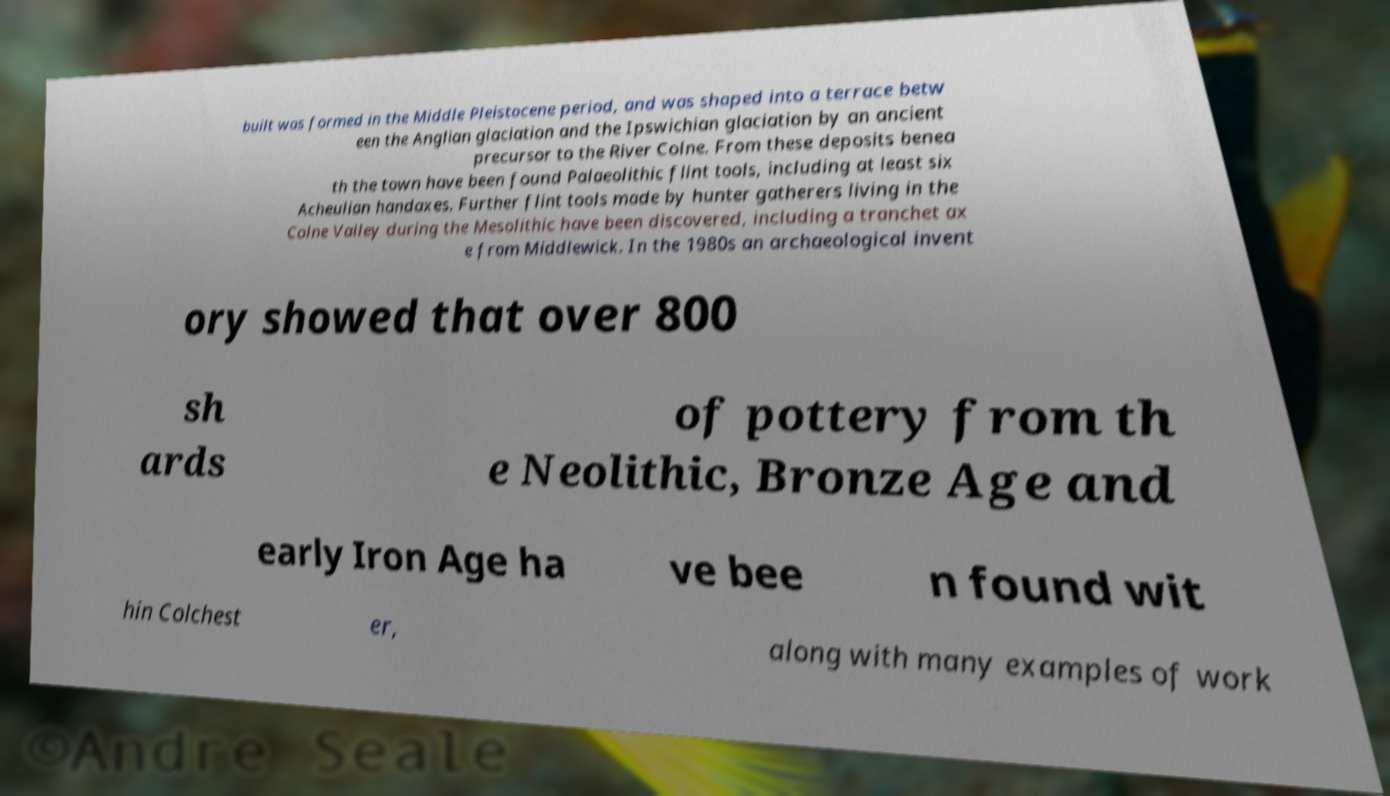For documentation purposes, I need the text within this image transcribed. Could you provide that? built was formed in the Middle Pleistocene period, and was shaped into a terrace betw een the Anglian glaciation and the Ipswichian glaciation by an ancient precursor to the River Colne. From these deposits benea th the town have been found Palaeolithic flint tools, including at least six Acheulian handaxes. Further flint tools made by hunter gatherers living in the Colne Valley during the Mesolithic have been discovered, including a tranchet ax e from Middlewick. In the 1980s an archaeological invent ory showed that over 800 sh ards of pottery from th e Neolithic, Bronze Age and early Iron Age ha ve bee n found wit hin Colchest er, along with many examples of work 